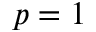<formula> <loc_0><loc_0><loc_500><loc_500>p = 1</formula> 